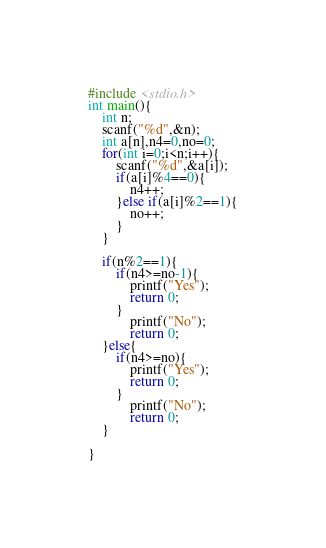Convert code to text. <code><loc_0><loc_0><loc_500><loc_500><_C_>#include <stdio.h>
int main(){
    int n;
    scanf("%d",&n);
    int a[n],n4=0,no=0;
    for(int i=0;i<n;i++){
        scanf("%d",&a[i]);
        if(a[i]%4==0){
            n4++;
        }else if(a[i]%2==1){
            no++;
        }
    }
    
    if(n%2==1){
        if(n4>=no-1){
            printf("Yes");
            return 0;
        }
            printf("No");
            return 0;
    }else{
        if(n4>=no){
            printf("Yes");
            return 0;
        }
            printf("No");
            return 0;
    }
    
}</code> 